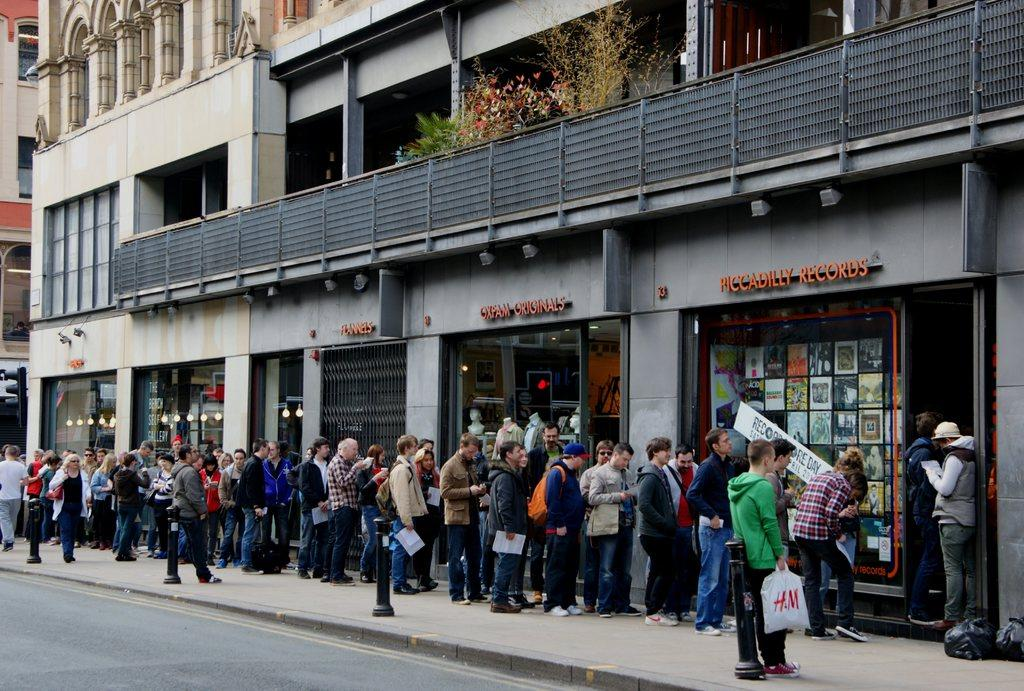<image>
Describe the image concisely. A line of people wait outside the front door of Piccadilly Records. 